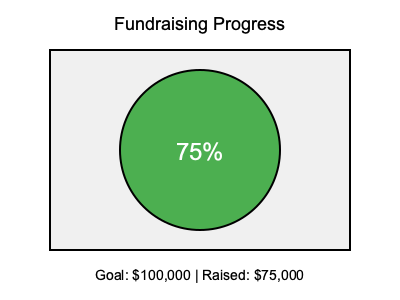In designing an eye-catching infographic to visualize fundraising goals and progress, which element in the provided graphic is most effective at immediately conveying the campaign's current status, and why? To answer this question, let's analyze the elements of the infographic:

1. Title: "Fundraising Progress" provides context but doesn't show the status.

2. Rectangle: Serves as a container for the information but doesn't convey progress.

3. Circle: This is the key element. It's a pie chart filled to 75%, which visually represents the progress.

4. Percentage: "75%" inside the circle reinforces the visual representation.

5. Text at the bottom: Provides detailed information but requires more time to process.

The circle (pie chart) is most effective because:

a) It's the largest and most prominent visual element.
b) The green color draws attention and implies positivity.
c) The circular shape allows for quick visual processing of the proportion filled.
d) It doesn't require reading text to understand the basic progress level.

Human perception is drawn to shapes and colors before text. The circular progress indicator (pie chart) provides an instant, intuitive understanding of the campaign's status without requiring the viewer to read or process numbers.
Answer: The circular pie chart, showing 75% completion. 